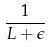<formula> <loc_0><loc_0><loc_500><loc_500>\frac { 1 } { L + \epsilon }</formula> 